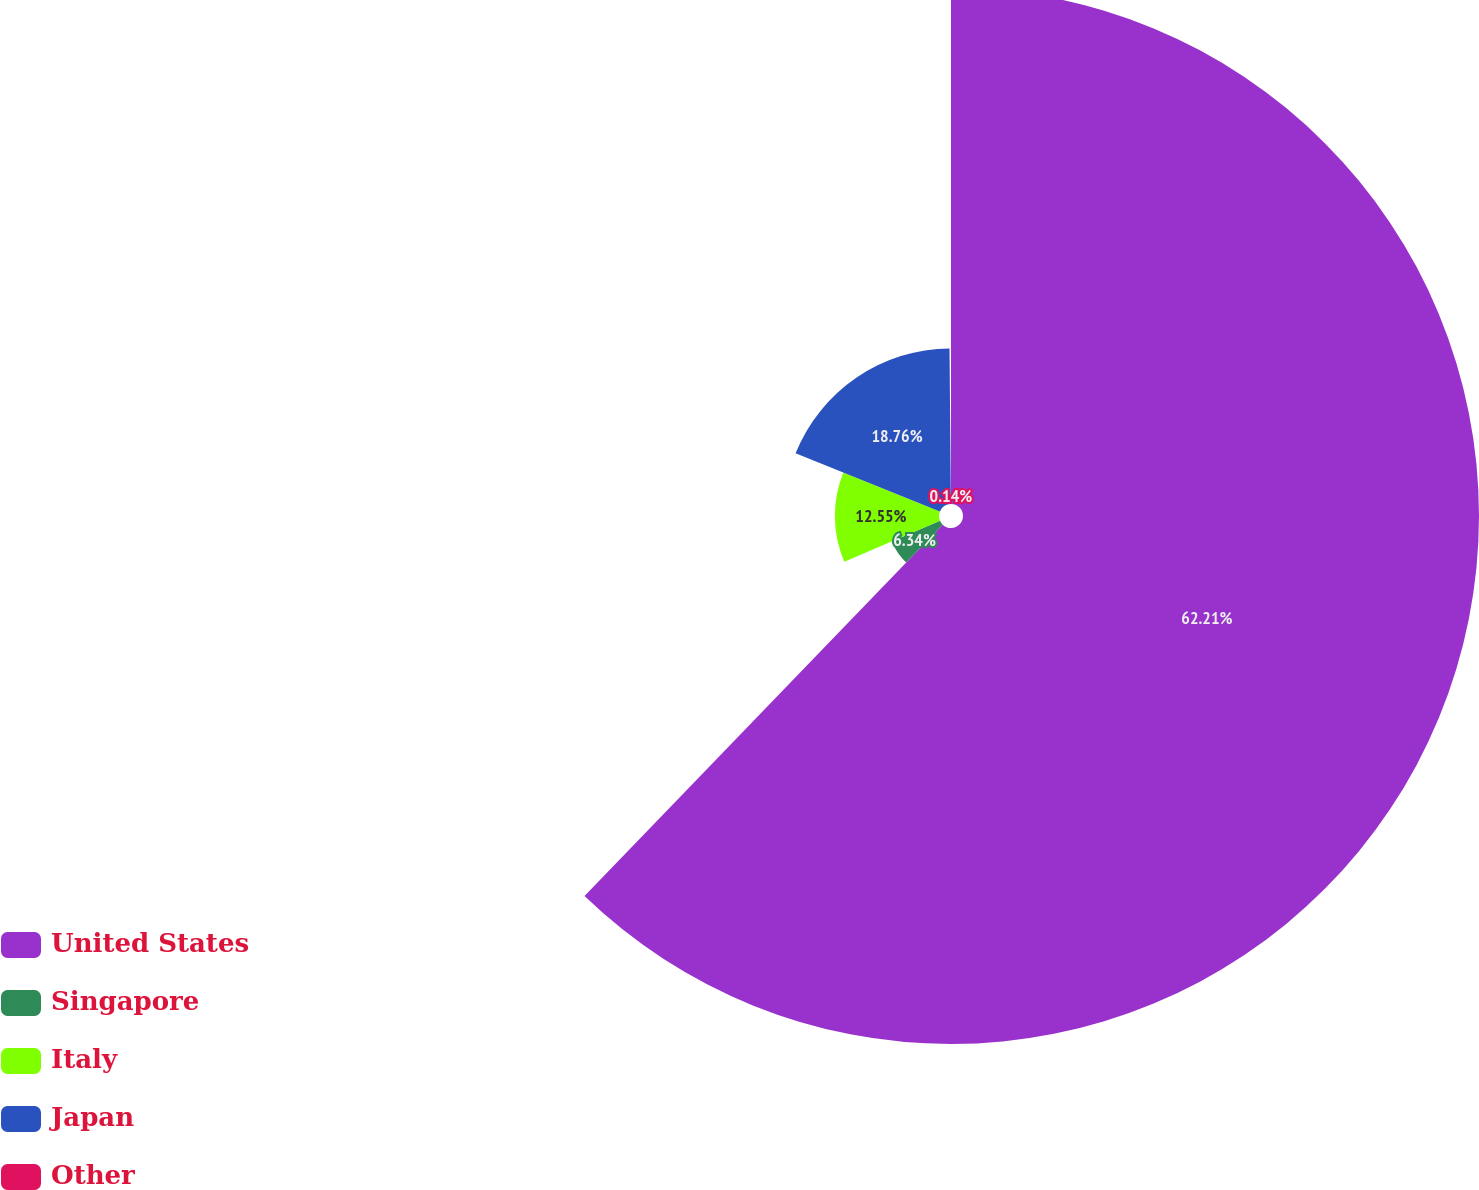Convert chart to OTSL. <chart><loc_0><loc_0><loc_500><loc_500><pie_chart><fcel>United States<fcel>Singapore<fcel>Italy<fcel>Japan<fcel>Other<nl><fcel>62.21%<fcel>6.34%<fcel>12.55%<fcel>18.76%<fcel>0.14%<nl></chart> 